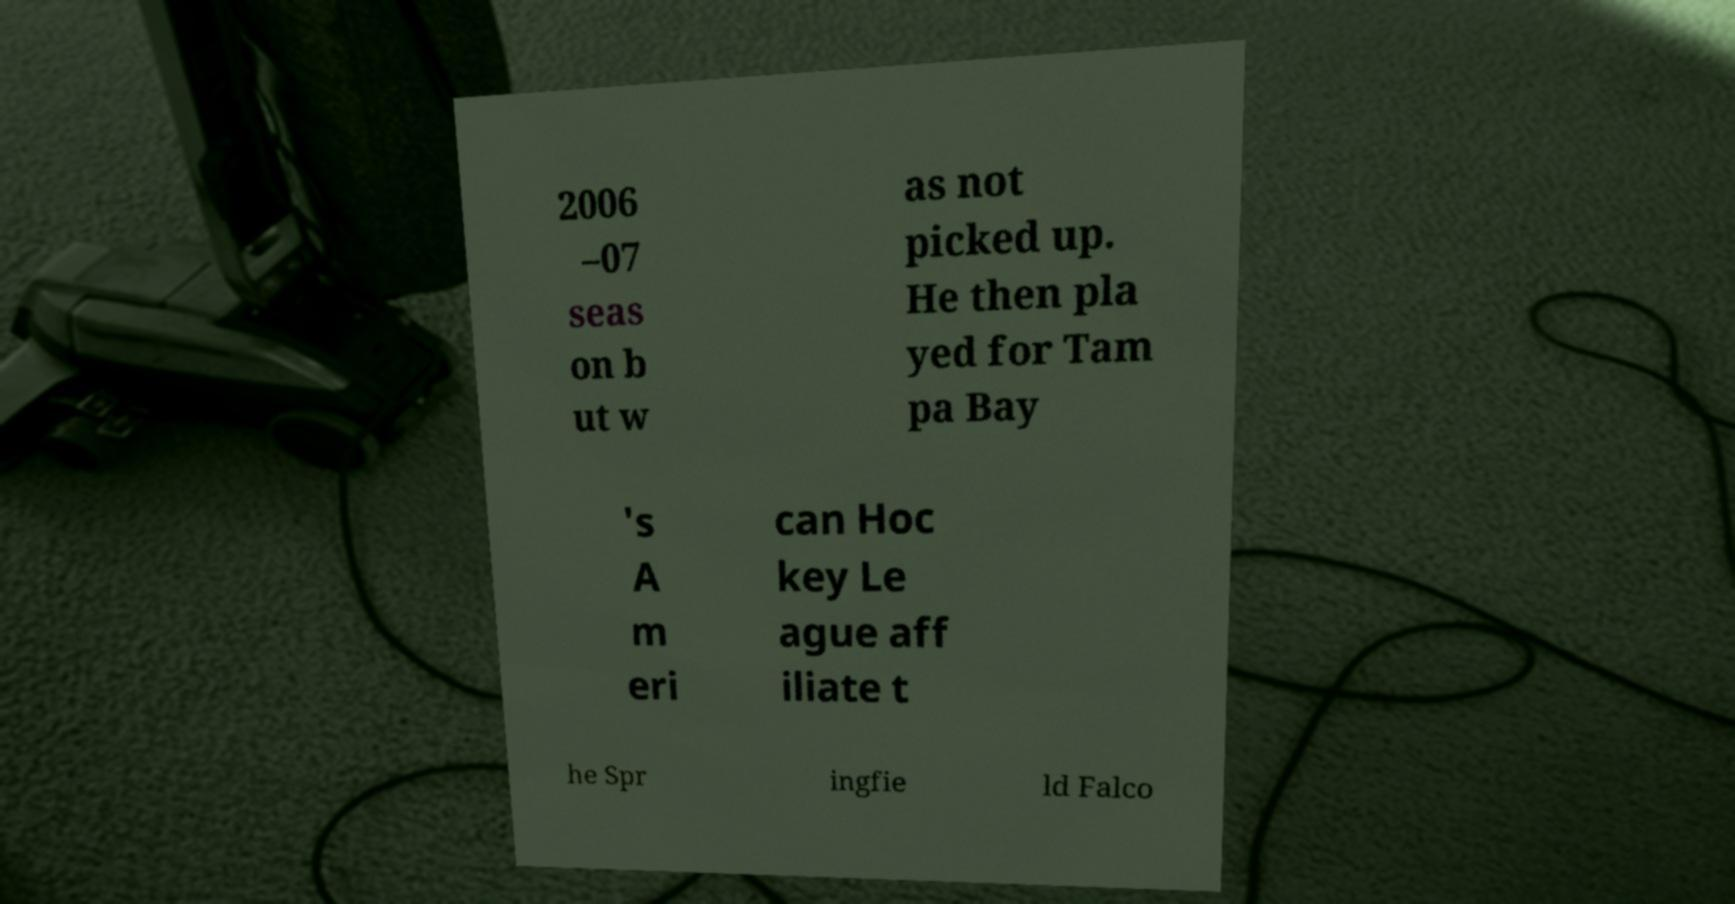There's text embedded in this image that I need extracted. Can you transcribe it verbatim? 2006 –07 seas on b ut w as not picked up. He then pla yed for Tam pa Bay 's A m eri can Hoc key Le ague aff iliate t he Spr ingfie ld Falco 